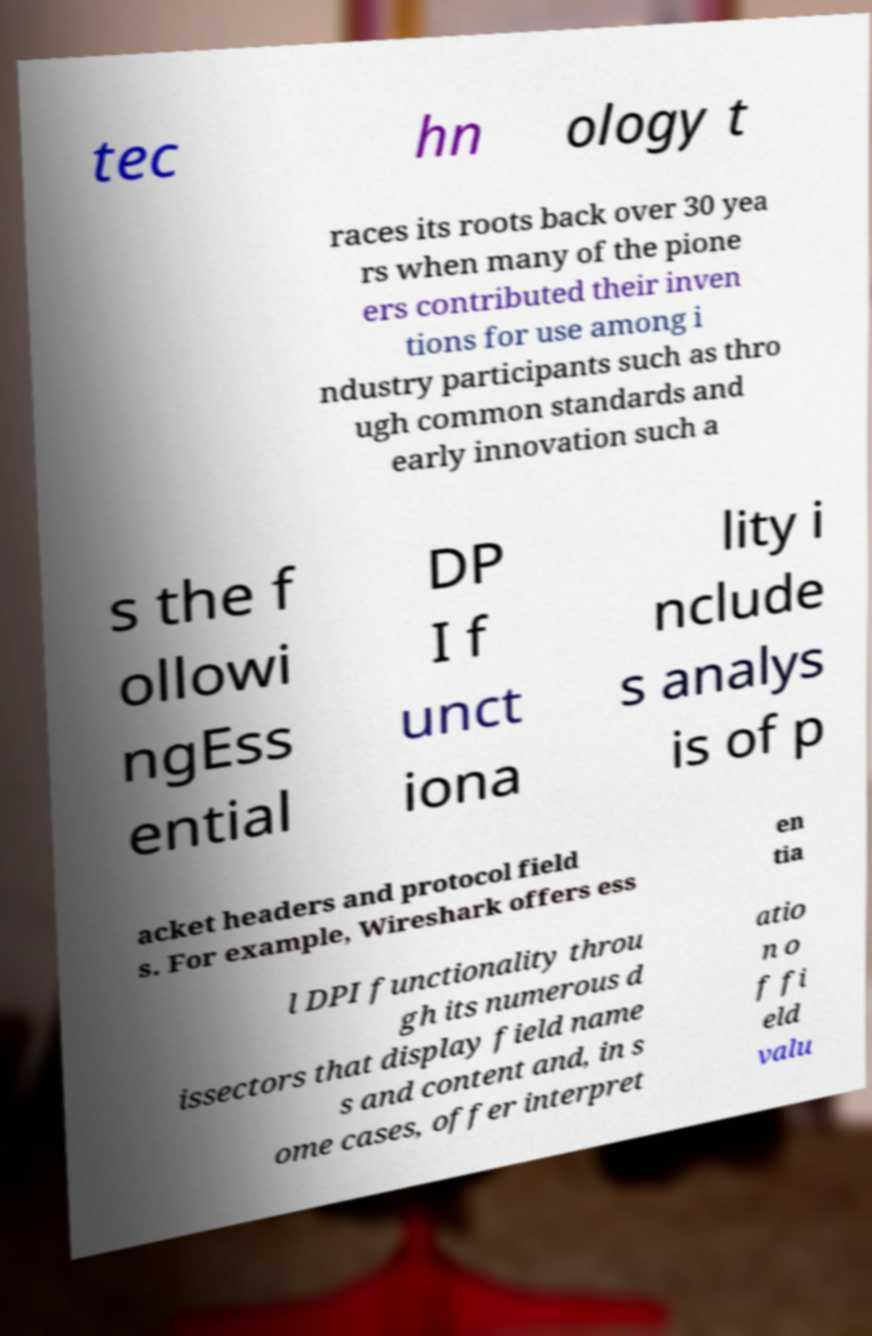Can you read and provide the text displayed in the image?This photo seems to have some interesting text. Can you extract and type it out for me? tec hn ology t races its roots back over 30 yea rs when many of the pione ers contributed their inven tions for use among i ndustry participants such as thro ugh common standards and early innovation such a s the f ollowi ngEss ential DP I f unct iona lity i nclude s analys is of p acket headers and protocol field s. For example, Wireshark offers ess en tia l DPI functionality throu gh its numerous d issectors that display field name s and content and, in s ome cases, offer interpret atio n o f fi eld valu 